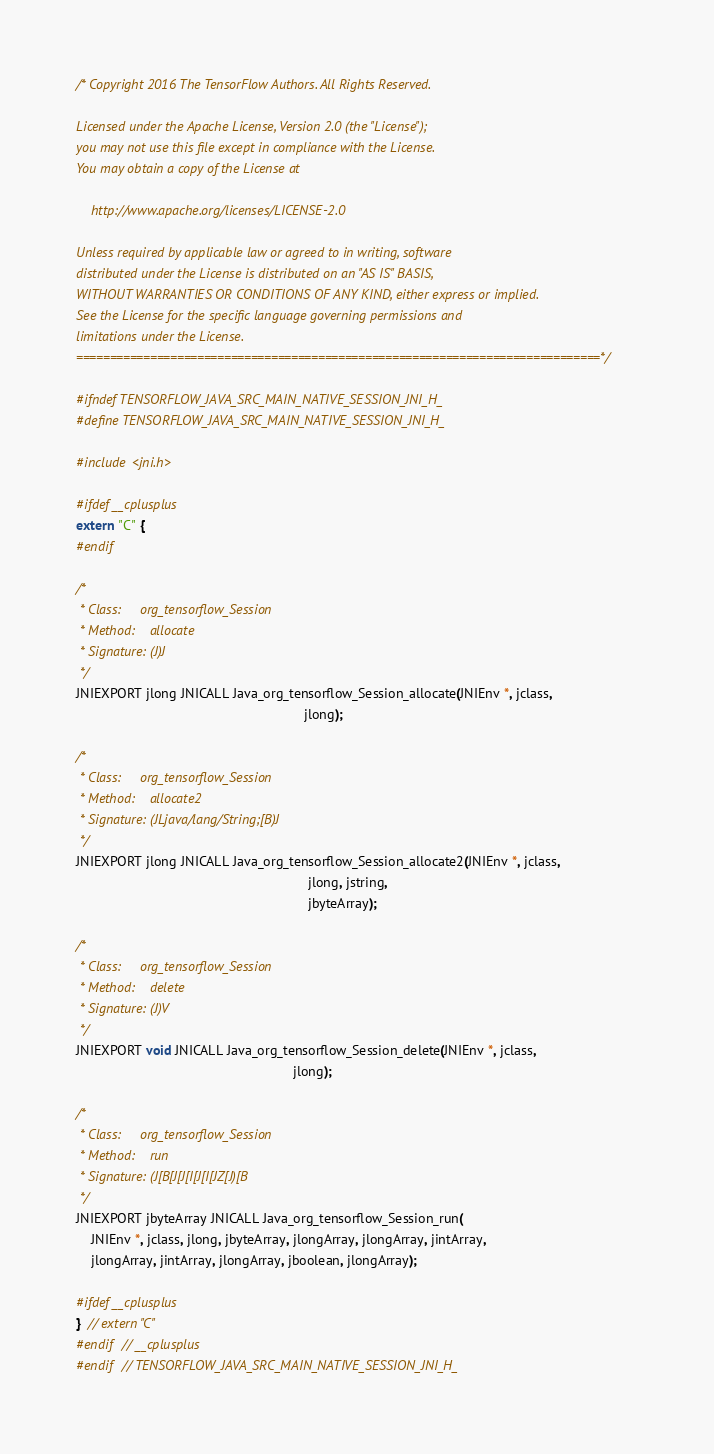<code> <loc_0><loc_0><loc_500><loc_500><_C_>/* Copyright 2016 The TensorFlow Authors. All Rights Reserved.

Licensed under the Apache License, Version 2.0 (the "License");
you may not use this file except in compliance with the License.
You may obtain a copy of the License at

    http://www.apache.org/licenses/LICENSE-2.0

Unless required by applicable law or agreed to in writing, software
distributed under the License is distributed on an "AS IS" BASIS,
WITHOUT WARRANTIES OR CONDITIONS OF ANY KIND, either express or implied.
See the License for the specific language governing permissions and
limitations under the License.
==============================================================================*/

#ifndef TENSORFLOW_JAVA_SRC_MAIN_NATIVE_SESSION_JNI_H_
#define TENSORFLOW_JAVA_SRC_MAIN_NATIVE_SESSION_JNI_H_

#include <jni.h>

#ifdef __cplusplus
extern "C" {
#endif

/*
 * Class:     org_tensorflow_Session
 * Method:    allocate
 * Signature: (J)J
 */
JNIEXPORT jlong JNICALL Java_org_tensorflow_Session_allocate(JNIEnv *, jclass,
                                                             jlong);

/*
 * Class:     org_tensorflow_Session
 * Method:    allocate2
 * Signature: (JLjava/lang/String;[B)J
 */
JNIEXPORT jlong JNICALL Java_org_tensorflow_Session_allocate2(JNIEnv *, jclass,
                                                              jlong, jstring,
                                                              jbyteArray);

/*
 * Class:     org_tensorflow_Session
 * Method:    delete
 * Signature: (J)V
 */
JNIEXPORT void JNICALL Java_org_tensorflow_Session_delete(JNIEnv *, jclass,
                                                          jlong);

/*
 * Class:     org_tensorflow_Session
 * Method:    run
 * Signature: (J[B[J[J[I[J[I[JZ[J)[B
 */
JNIEXPORT jbyteArray JNICALL Java_org_tensorflow_Session_run(
    JNIEnv *, jclass, jlong, jbyteArray, jlongArray, jlongArray, jintArray,
    jlongArray, jintArray, jlongArray, jboolean, jlongArray);

#ifdef __cplusplus
}  // extern "C"
#endif  // __cplusplus
#endif  // TENSORFLOW_JAVA_SRC_MAIN_NATIVE_SESSION_JNI_H_
</code> 